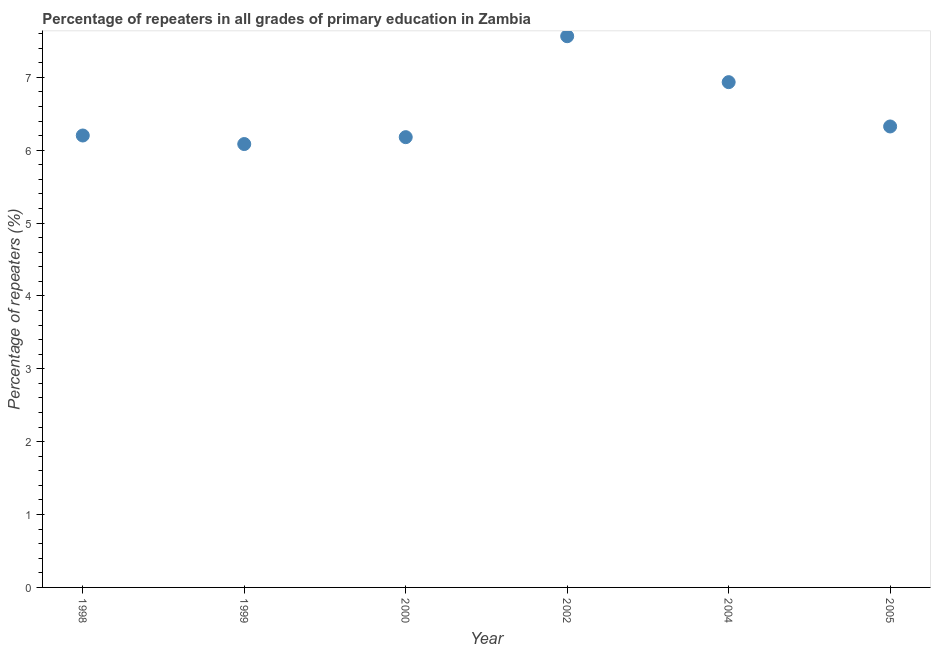What is the percentage of repeaters in primary education in 1999?
Provide a succinct answer. 6.09. Across all years, what is the maximum percentage of repeaters in primary education?
Your answer should be compact. 7.56. Across all years, what is the minimum percentage of repeaters in primary education?
Provide a short and direct response. 6.09. What is the sum of the percentage of repeaters in primary education?
Give a very brief answer. 39.29. What is the difference between the percentage of repeaters in primary education in 1999 and 2004?
Your answer should be compact. -0.85. What is the average percentage of repeaters in primary education per year?
Offer a very short reply. 6.55. What is the median percentage of repeaters in primary education?
Make the answer very short. 6.26. In how many years, is the percentage of repeaters in primary education greater than 5.2 %?
Your response must be concise. 6. What is the ratio of the percentage of repeaters in primary education in 1999 to that in 2000?
Keep it short and to the point. 0.98. What is the difference between the highest and the second highest percentage of repeaters in primary education?
Provide a short and direct response. 0.63. What is the difference between the highest and the lowest percentage of repeaters in primary education?
Provide a succinct answer. 1.48. In how many years, is the percentage of repeaters in primary education greater than the average percentage of repeaters in primary education taken over all years?
Your answer should be compact. 2. How many dotlines are there?
Make the answer very short. 1. How many years are there in the graph?
Your answer should be very brief. 6. What is the difference between two consecutive major ticks on the Y-axis?
Make the answer very short. 1. Does the graph contain grids?
Provide a succinct answer. No. What is the title of the graph?
Your answer should be very brief. Percentage of repeaters in all grades of primary education in Zambia. What is the label or title of the X-axis?
Provide a succinct answer. Year. What is the label or title of the Y-axis?
Make the answer very short. Percentage of repeaters (%). What is the Percentage of repeaters (%) in 1998?
Give a very brief answer. 6.2. What is the Percentage of repeaters (%) in 1999?
Make the answer very short. 6.09. What is the Percentage of repeaters (%) in 2000?
Provide a succinct answer. 6.18. What is the Percentage of repeaters (%) in 2002?
Provide a succinct answer. 7.56. What is the Percentage of repeaters (%) in 2004?
Keep it short and to the point. 6.93. What is the Percentage of repeaters (%) in 2005?
Offer a terse response. 6.33. What is the difference between the Percentage of repeaters (%) in 1998 and 1999?
Your answer should be very brief. 0.12. What is the difference between the Percentage of repeaters (%) in 1998 and 2000?
Provide a succinct answer. 0.02. What is the difference between the Percentage of repeaters (%) in 1998 and 2002?
Offer a terse response. -1.36. What is the difference between the Percentage of repeaters (%) in 1998 and 2004?
Give a very brief answer. -0.73. What is the difference between the Percentage of repeaters (%) in 1998 and 2005?
Provide a succinct answer. -0.12. What is the difference between the Percentage of repeaters (%) in 1999 and 2000?
Your answer should be compact. -0.09. What is the difference between the Percentage of repeaters (%) in 1999 and 2002?
Provide a succinct answer. -1.48. What is the difference between the Percentage of repeaters (%) in 1999 and 2004?
Give a very brief answer. -0.85. What is the difference between the Percentage of repeaters (%) in 1999 and 2005?
Offer a very short reply. -0.24. What is the difference between the Percentage of repeaters (%) in 2000 and 2002?
Offer a terse response. -1.39. What is the difference between the Percentage of repeaters (%) in 2000 and 2004?
Keep it short and to the point. -0.75. What is the difference between the Percentage of repeaters (%) in 2000 and 2005?
Give a very brief answer. -0.15. What is the difference between the Percentage of repeaters (%) in 2002 and 2004?
Offer a very short reply. 0.63. What is the difference between the Percentage of repeaters (%) in 2002 and 2005?
Ensure brevity in your answer.  1.24. What is the difference between the Percentage of repeaters (%) in 2004 and 2005?
Make the answer very short. 0.61. What is the ratio of the Percentage of repeaters (%) in 1998 to that in 2002?
Give a very brief answer. 0.82. What is the ratio of the Percentage of repeaters (%) in 1998 to that in 2004?
Give a very brief answer. 0.89. What is the ratio of the Percentage of repeaters (%) in 1998 to that in 2005?
Make the answer very short. 0.98. What is the ratio of the Percentage of repeaters (%) in 1999 to that in 2000?
Provide a short and direct response. 0.98. What is the ratio of the Percentage of repeaters (%) in 1999 to that in 2002?
Provide a short and direct response. 0.8. What is the ratio of the Percentage of repeaters (%) in 1999 to that in 2004?
Give a very brief answer. 0.88. What is the ratio of the Percentage of repeaters (%) in 1999 to that in 2005?
Provide a short and direct response. 0.96. What is the ratio of the Percentage of repeaters (%) in 2000 to that in 2002?
Offer a very short reply. 0.82. What is the ratio of the Percentage of repeaters (%) in 2000 to that in 2004?
Provide a short and direct response. 0.89. What is the ratio of the Percentage of repeaters (%) in 2002 to that in 2004?
Provide a short and direct response. 1.09. What is the ratio of the Percentage of repeaters (%) in 2002 to that in 2005?
Offer a very short reply. 1.2. What is the ratio of the Percentage of repeaters (%) in 2004 to that in 2005?
Provide a succinct answer. 1.1. 